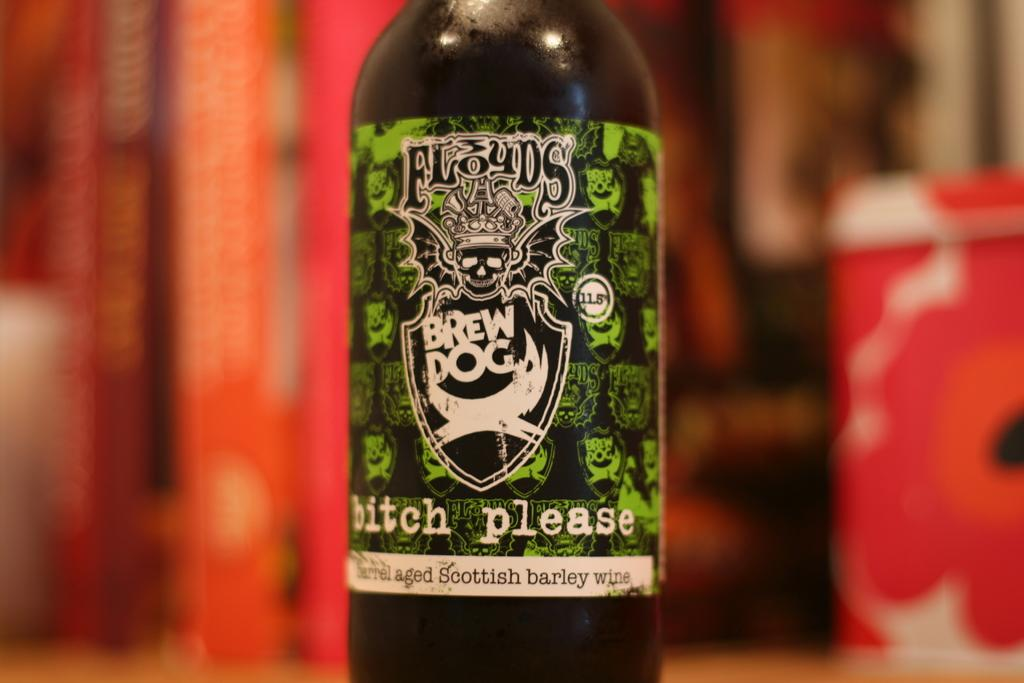<image>
Relay a brief, clear account of the picture shown. A bottle of Floyds Brew Dog wine has a profane name printed at the bottom of the label. 